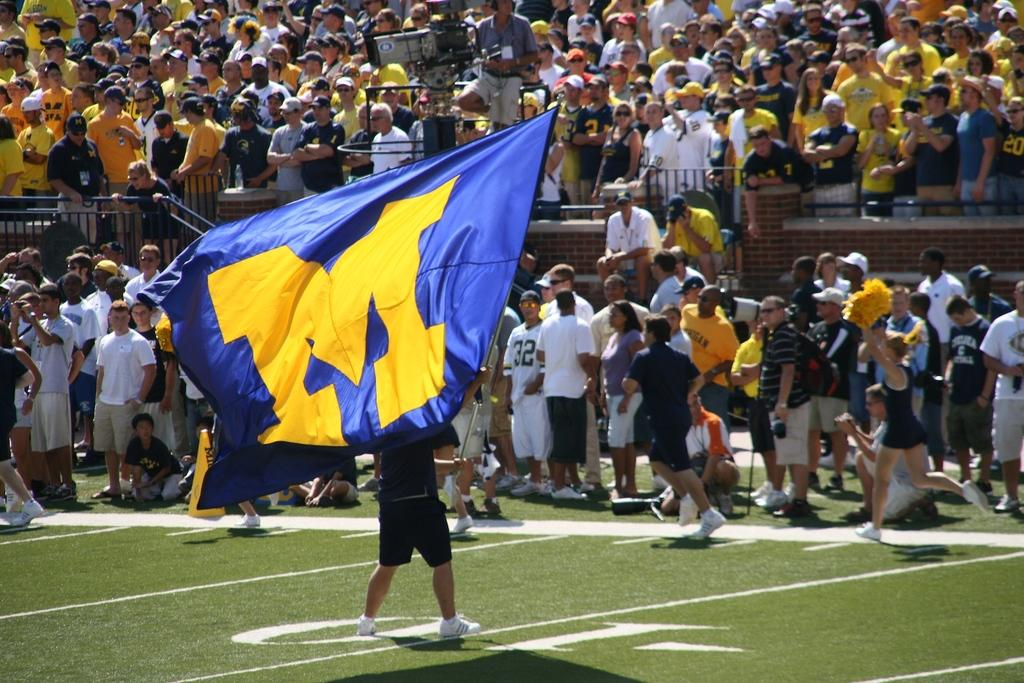<image>
Summarize the visual content of the image. a person holding a M flag that is gold and blue 